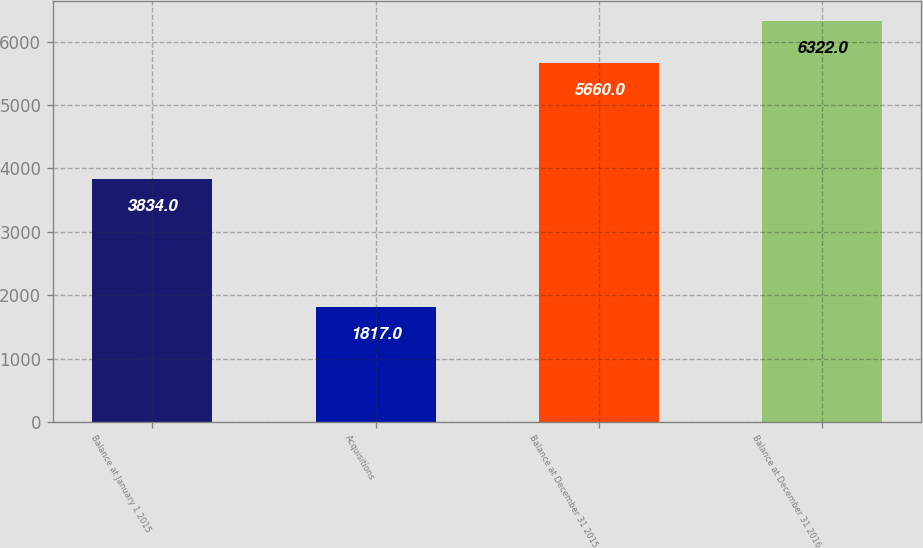<chart> <loc_0><loc_0><loc_500><loc_500><bar_chart><fcel>Balance at January 1 2015<fcel>Acquisitions<fcel>Balance at December 31 2015<fcel>Balance at December 31 2016<nl><fcel>3834<fcel>1817<fcel>5660<fcel>6322<nl></chart> 